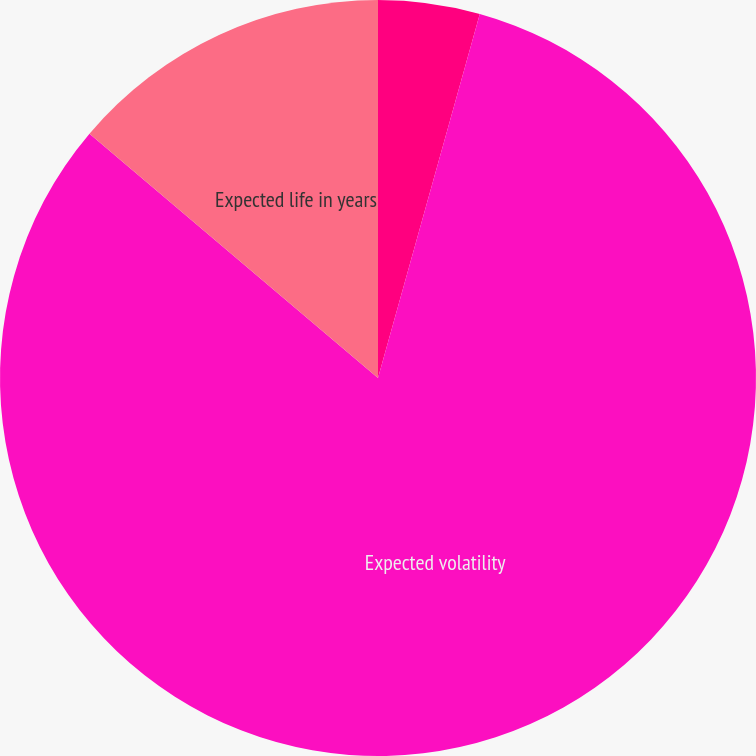Convert chart to OTSL. <chart><loc_0><loc_0><loc_500><loc_500><pie_chart><fcel>Risk-free interest rate<fcel>Expected volatility<fcel>Expected life in years<nl><fcel>4.34%<fcel>81.84%<fcel>13.82%<nl></chart> 